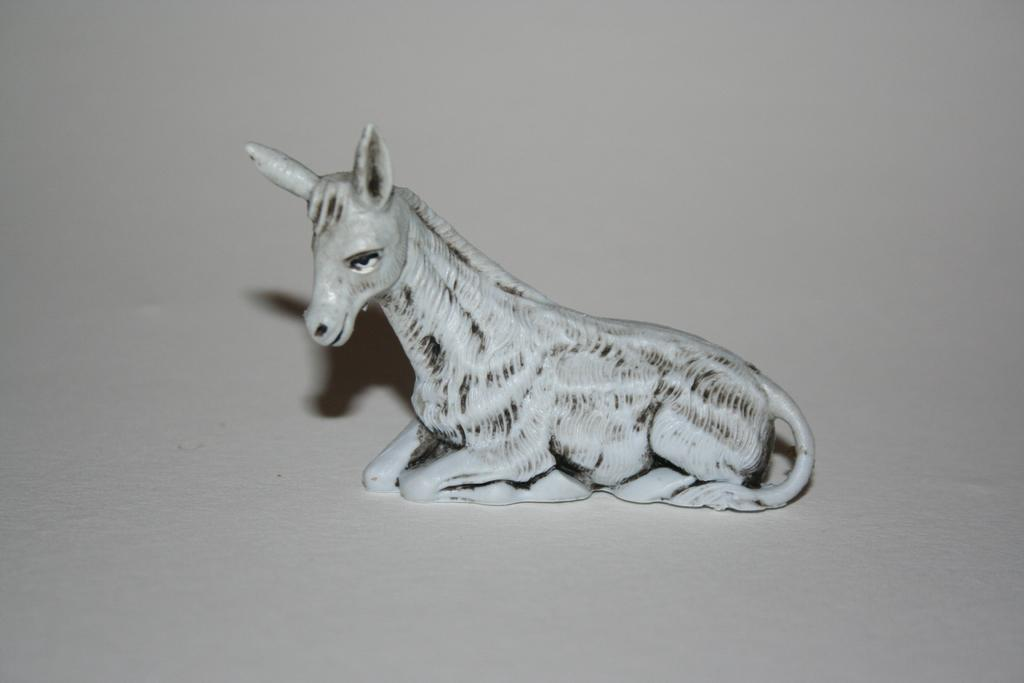What type of toy is present in the image? There is a horse toy in the image. Where is the horse toy located in the image? The horse toy is placed on the ground. What type of protest is happening in the image? There is no protest present in the image; it only features a horse toy placed on the ground. What type of carpentry work is being done in the image? There is no carpentry work or carpenter present in the image; it only features a horse toy placed on the ground. 